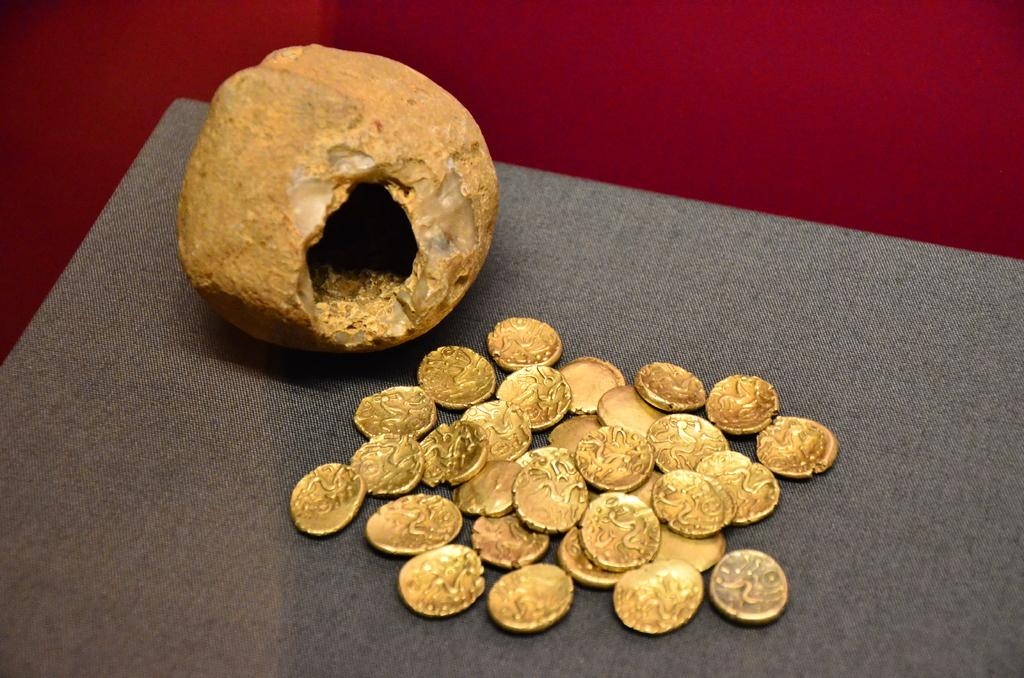What object is the main focus of the image? There is a piggy bank in the image. What can be seen on the table in the image? There are coins on the table in the image. What is visible in the background of the image? There is a wall visible in the background of the image. How many doors can be seen in the image? There are no doors visible in the image. What is the fifth thing in the image? The provided facts only mention three items (piggy bank, coins, and wall), so it's impossible to determine a fifth thing. 